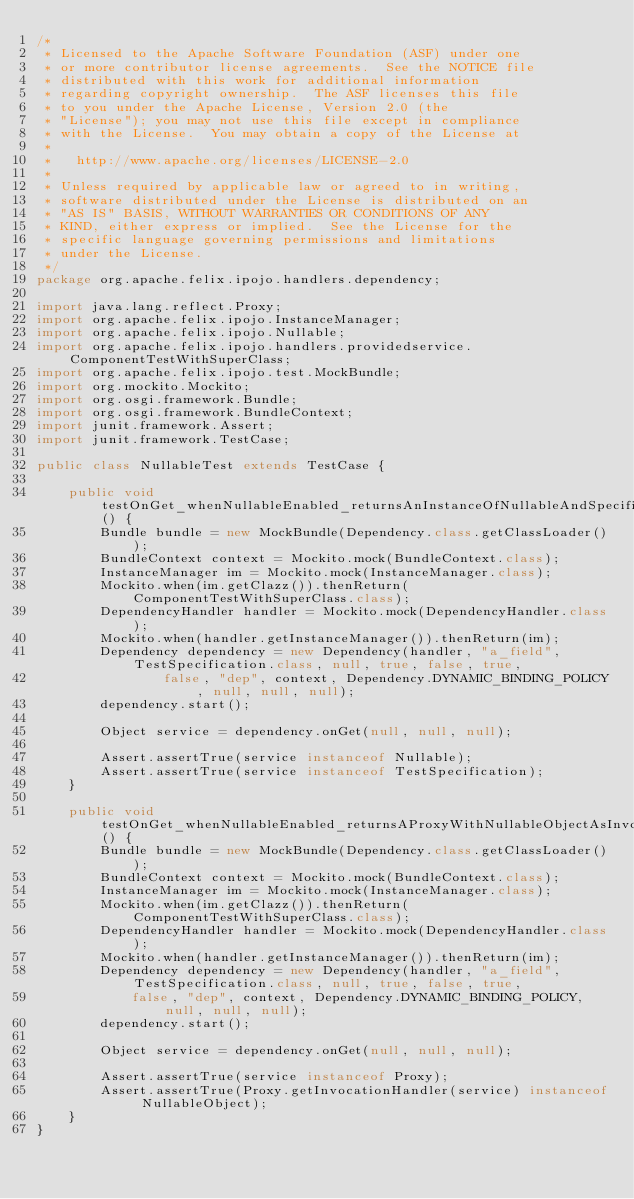Convert code to text. <code><loc_0><loc_0><loc_500><loc_500><_Java_>/*
 * Licensed to the Apache Software Foundation (ASF) under one
 * or more contributor license agreements.  See the NOTICE file
 * distributed with this work for additional information
 * regarding copyright ownership.  The ASF licenses this file
 * to you under the Apache License, Version 2.0 (the
 * "License"); you may not use this file except in compliance
 * with the License.  You may obtain a copy of the License at
 *
 *   http://www.apache.org/licenses/LICENSE-2.0
 *
 * Unless required by applicable law or agreed to in writing,
 * software distributed under the License is distributed on an
 * "AS IS" BASIS, WITHOUT WARRANTIES OR CONDITIONS OF ANY
 * KIND, either express or implied.  See the License for the
 * specific language governing permissions and limitations
 * under the License.
 */
package org.apache.felix.ipojo.handlers.dependency;

import java.lang.reflect.Proxy;
import org.apache.felix.ipojo.InstanceManager;
import org.apache.felix.ipojo.Nullable;
import org.apache.felix.ipojo.handlers.providedservice.ComponentTestWithSuperClass;
import org.apache.felix.ipojo.test.MockBundle;
import org.mockito.Mockito;
import org.osgi.framework.Bundle;
import org.osgi.framework.BundleContext;
import junit.framework.Assert;
import junit.framework.TestCase;

public class NullableTest extends TestCase {

    public void testOnGet_whenNullableEnabled_returnsAnInstanceOfNullableAndSpecification() {
        Bundle bundle = new MockBundle(Dependency.class.getClassLoader());
        BundleContext context = Mockito.mock(BundleContext.class);
        InstanceManager im = Mockito.mock(InstanceManager.class);
        Mockito.when(im.getClazz()).thenReturn(ComponentTestWithSuperClass.class);
        DependencyHandler handler = Mockito.mock(DependencyHandler.class);
        Mockito.when(handler.getInstanceManager()).thenReturn(im);
        Dependency dependency = new Dependency(handler, "a_field", TestSpecification.class, null, true, false, true,
                false, "dep", context, Dependency.DYNAMIC_BINDING_POLICY, null, null, null);
        dependency.start();

        Object service = dependency.onGet(null, null, null);

        Assert.assertTrue(service instanceof Nullable);
        Assert.assertTrue(service instanceof TestSpecification);
    }

    public void testOnGet_whenNullableEnabled_returnsAProxyWithNullableObjectAsInvocationHandler() {
        Bundle bundle = new MockBundle(Dependency.class.getClassLoader());
        BundleContext context = Mockito.mock(BundleContext.class);
        InstanceManager im = Mockito.mock(InstanceManager.class);
        Mockito.when(im.getClazz()).thenReturn(ComponentTestWithSuperClass.class);
        DependencyHandler handler = Mockito.mock(DependencyHandler.class);
        Mockito.when(handler.getInstanceManager()).thenReturn(im);
        Dependency dependency = new Dependency(handler, "a_field", TestSpecification.class, null, true, false, true,
            false, "dep", context, Dependency.DYNAMIC_BINDING_POLICY, null, null, null);
        dependency.start();

        Object service = dependency.onGet(null, null, null);

        Assert.assertTrue(service instanceof Proxy);
        Assert.assertTrue(Proxy.getInvocationHandler(service) instanceof NullableObject);
    }
}</code> 